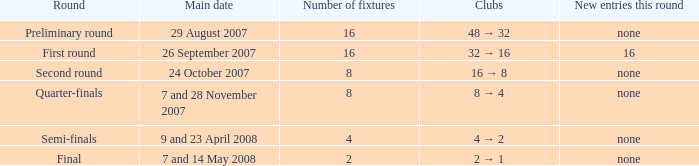What is the round when the count of fixtures is greater than 2, and the chief date of 7 and 28 november 2007? Quarter-finals. 